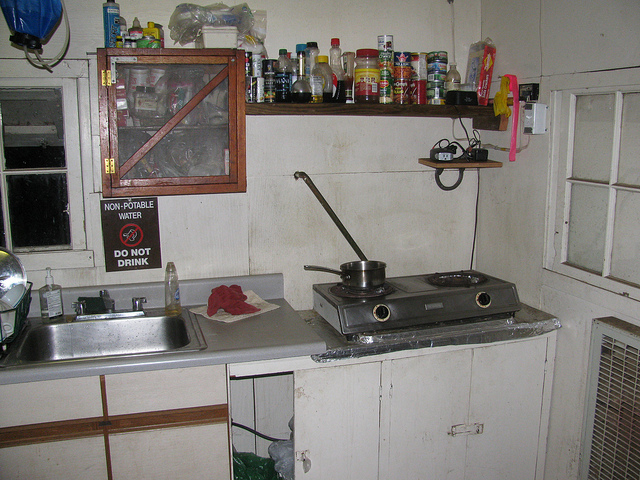Please extract the text content from this image. NON -POTABLE WATER DO NOT DRINK 